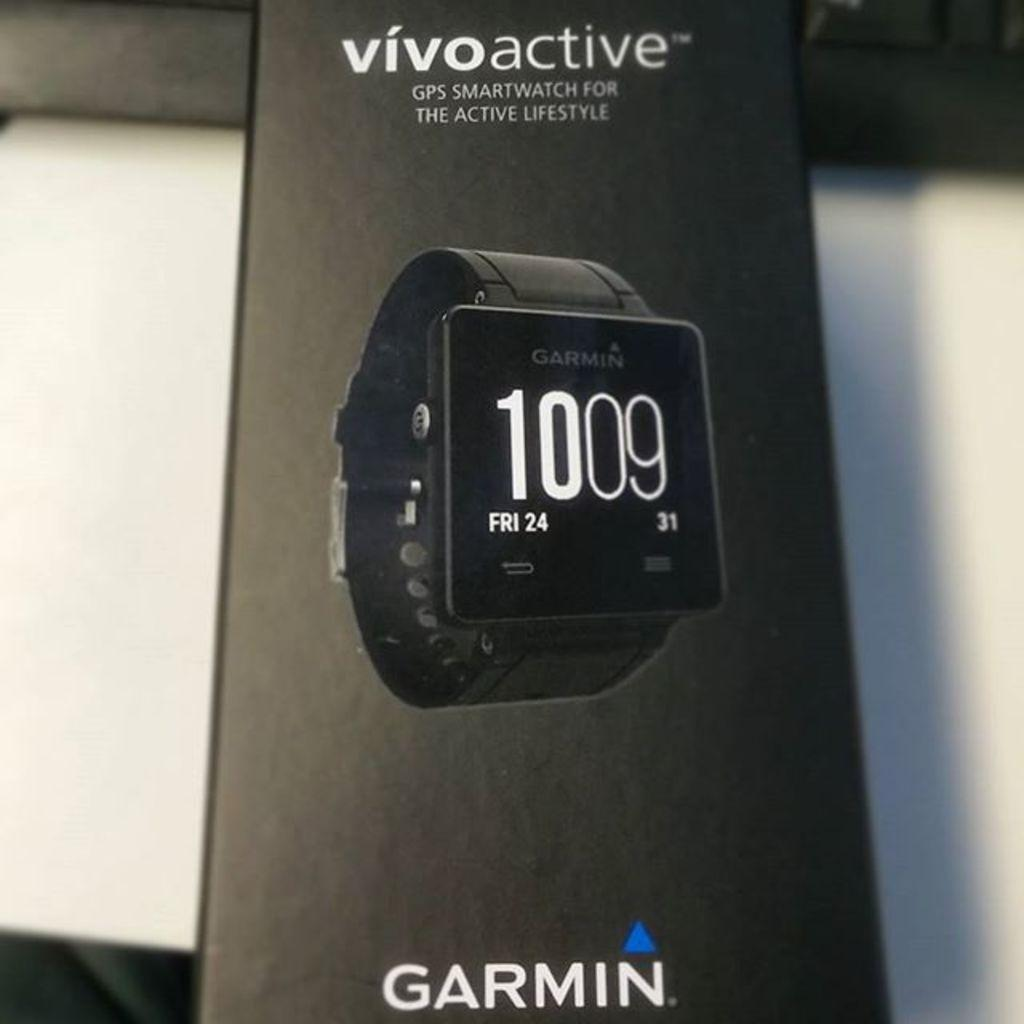<image>
Relay a brief, clear account of the picture shown. An ad for a Garmin smart watch is printed on a brochure. 